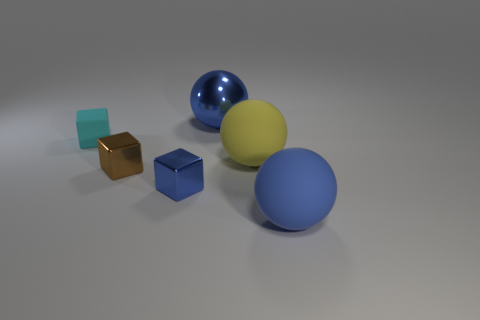Does the ball that is behind the small rubber thing have the same color as the tiny rubber thing?
Keep it short and to the point. No. What number of blue things are right of the blue object left of the big blue sphere that is behind the small matte object?
Make the answer very short. 2. There is a cyan rubber block; what number of small brown metallic cubes are behind it?
Provide a succinct answer. 0. There is a tiny matte thing that is the same shape as the tiny blue shiny thing; what is its color?
Make the answer very short. Cyan. The big thing that is both in front of the cyan rubber thing and behind the brown block is made of what material?
Your answer should be compact. Rubber. There is a blue ball on the left side of the blue matte sphere; does it have the same size as the tiny rubber cube?
Offer a terse response. No. What material is the tiny cyan object?
Your answer should be compact. Rubber. What color is the matte sphere that is to the right of the large yellow sphere?
Your answer should be very brief. Blue. What number of large things are red matte objects or blue things?
Offer a terse response. 2. There is a shiny ball that is right of the rubber cube; is it the same color as the metallic block in front of the small brown cube?
Make the answer very short. Yes. 